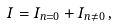<formula> <loc_0><loc_0><loc_500><loc_500>I = I _ { n = 0 } + I _ { n \neq 0 } \, ,</formula> 